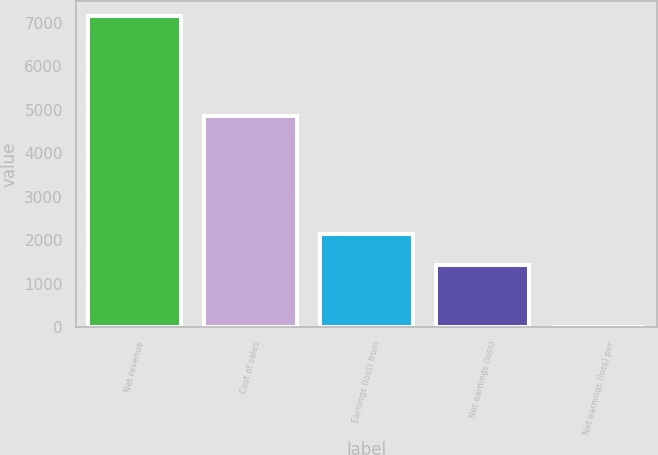<chart> <loc_0><loc_0><loc_500><loc_500><bar_chart><fcel>Net revenue<fcel>Cost of sales<fcel>Earnings (loss) from<fcel>Net earnings (loss)<fcel>Net earnings (loss) per<nl><fcel>7150<fcel>4845<fcel>2145.21<fcel>1430.24<fcel>0.3<nl></chart> 